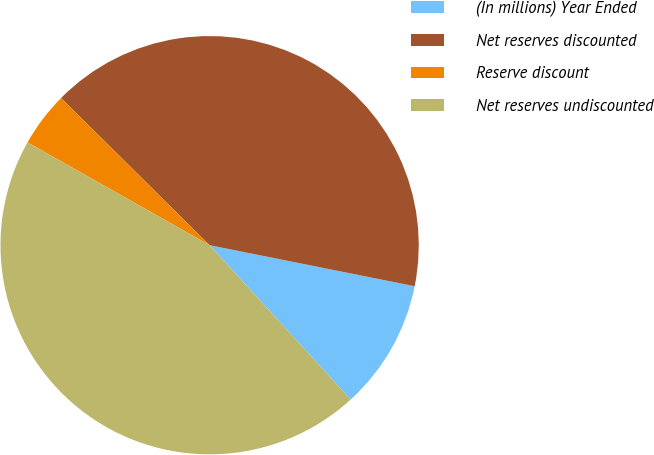Convert chart. <chart><loc_0><loc_0><loc_500><loc_500><pie_chart><fcel>(In millions) Year Ended<fcel>Net reserves discounted<fcel>Reserve discount<fcel>Net reserves undiscounted<nl><fcel>10.07%<fcel>40.72%<fcel>4.24%<fcel>44.97%<nl></chart> 